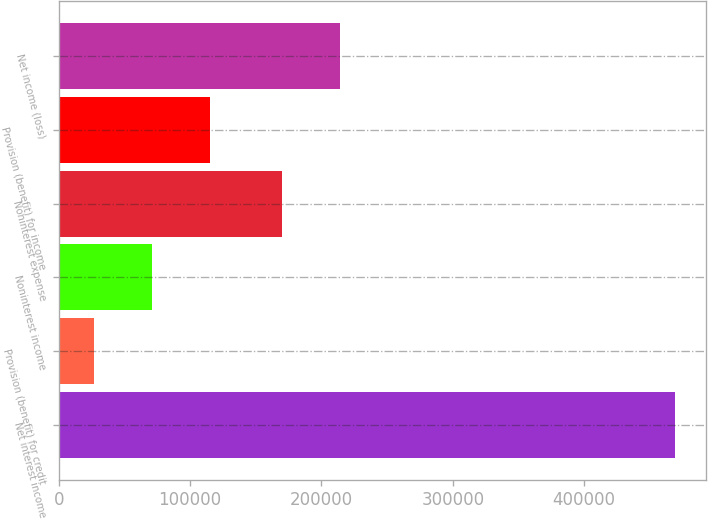<chart> <loc_0><loc_0><loc_500><loc_500><bar_chart><fcel>Net interest income<fcel>Provision (benefit) for credit<fcel>Noninterest income<fcel>Noninterest expense<fcel>Provision (benefit) for income<fcel>Net income (loss)<nl><fcel>468969<fcel>26922<fcel>71126.7<fcel>170276<fcel>115331<fcel>214481<nl></chart> 